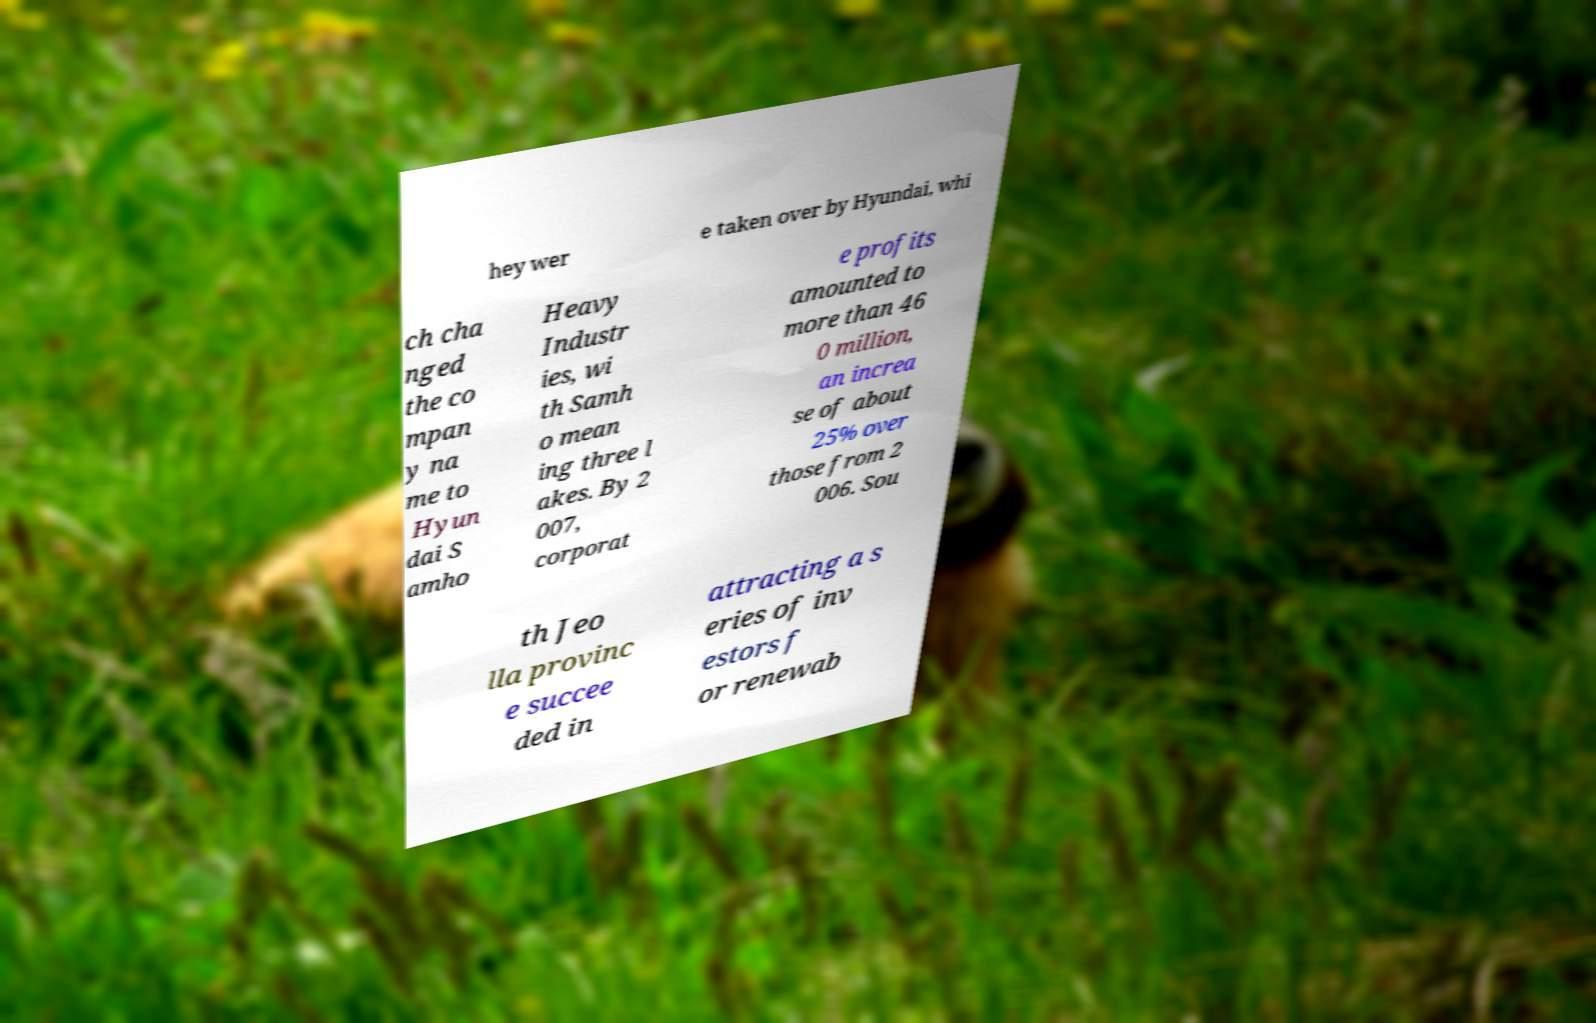Can you read and provide the text displayed in the image?This photo seems to have some interesting text. Can you extract and type it out for me? hey wer e taken over by Hyundai, whi ch cha nged the co mpan y na me to Hyun dai S amho Heavy Industr ies, wi th Samh o mean ing three l akes. By 2 007, corporat e profits amounted to more than 46 0 million, an increa se of about 25% over those from 2 006. Sou th Jeo lla provinc e succee ded in attracting a s eries of inv estors f or renewab 